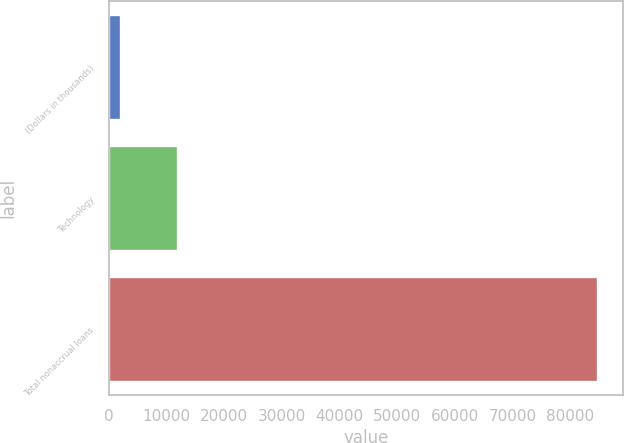<chart> <loc_0><loc_0><loc_500><loc_500><bar_chart><fcel>(Dollars in thousands)<fcel>Technology<fcel>Total nonaccrual loans<nl><fcel>2008<fcel>11967<fcel>84919<nl></chart> 